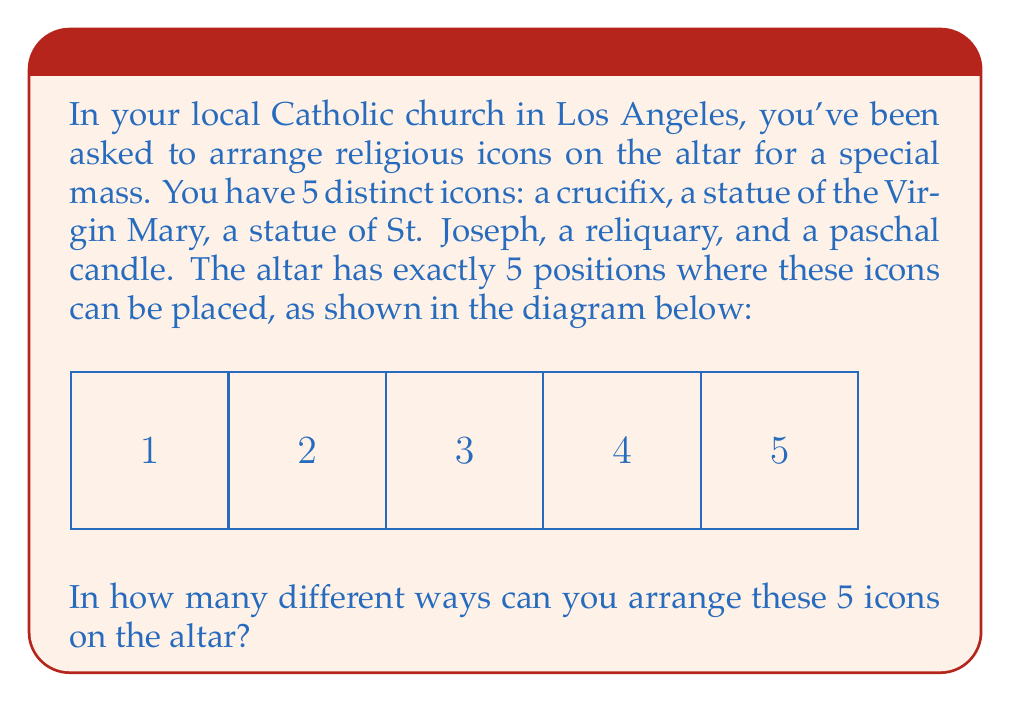Can you solve this math problem? Let's approach this step-by-step:

1) We have 5 distinct religious icons and 5 distinct positions on the altar.

2) This is a permutation problem, as the order matters (each arrangement is considered different) and we are using all the icons.

3) For the first position, we have 5 choices of icons to place.

4) After placing the first icon, we have 4 choices for the second position.

5) Following this pattern, we have:
   - 3 choices for the third position
   - 2 choices for the fourth position
   - Only 1 choice left for the last position

6) According to the multiplication principle, we multiply these numbers together:

   $$ 5 \times 4 \times 3 \times 2 \times 1 = 120 $$

7) This is also known as 5 factorial, written as $5!$

Therefore, there are 120 different ways to arrange the 5 religious icons on the altar.
Answer: $5! = 120$ ways 